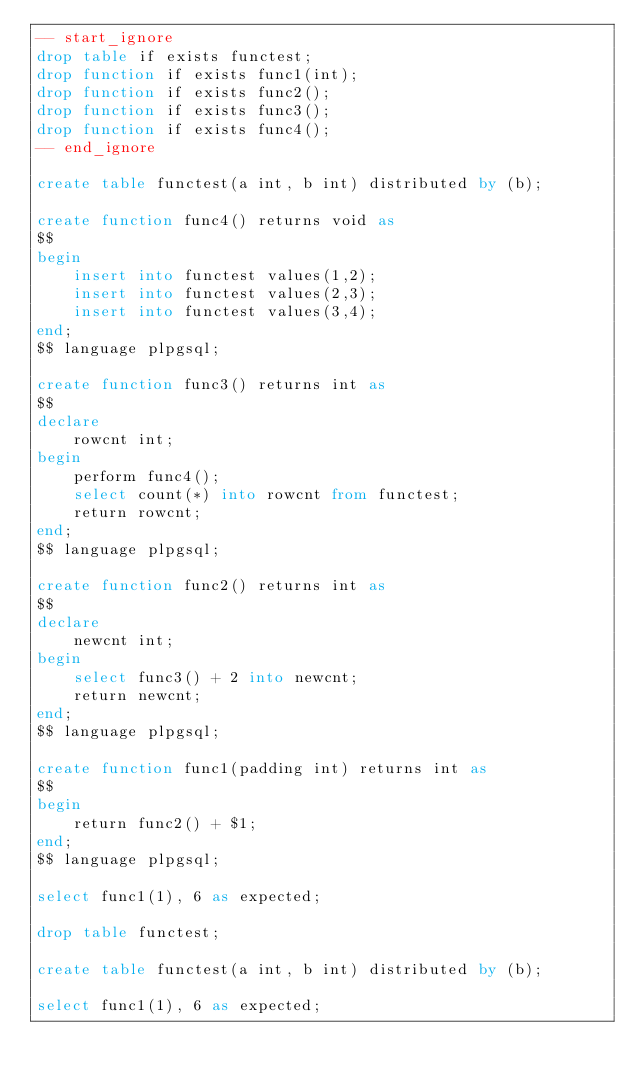<code> <loc_0><loc_0><loc_500><loc_500><_SQL_>-- start_ignore
drop table if exists functest;
drop function if exists func1(int);
drop function if exists func2();
drop function if exists func3();
drop function if exists func4();
-- end_ignore

create table functest(a int, b int) distributed by (b);

create function func4() returns void as
$$
begin
    insert into functest values(1,2);
    insert into functest values(2,3);
    insert into functest values(3,4);
end; 
$$ language plpgsql;

create function func3() returns int as
$$
declare 
    rowcnt int;
begin
    perform func4();
    select count(*) into rowcnt from functest;
    return rowcnt;
end;
$$ language plpgsql;

create function func2() returns int as
$$
declare 
    newcnt int;
begin
    select func3() + 2 into newcnt;
    return newcnt;
end;
$$ language plpgsql;

create function func1(padding int) returns int as
$$
begin
    return func2() + $1;
end;
$$ language plpgsql;

select func1(1), 6 as expected;

drop table functest;

create table functest(a int, b int) distributed by (b);

select func1(1), 6 as expected;

</code> 